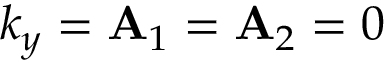<formula> <loc_0><loc_0><loc_500><loc_500>k _ { y } = { A } _ { 1 } = { A } _ { 2 } = 0</formula> 